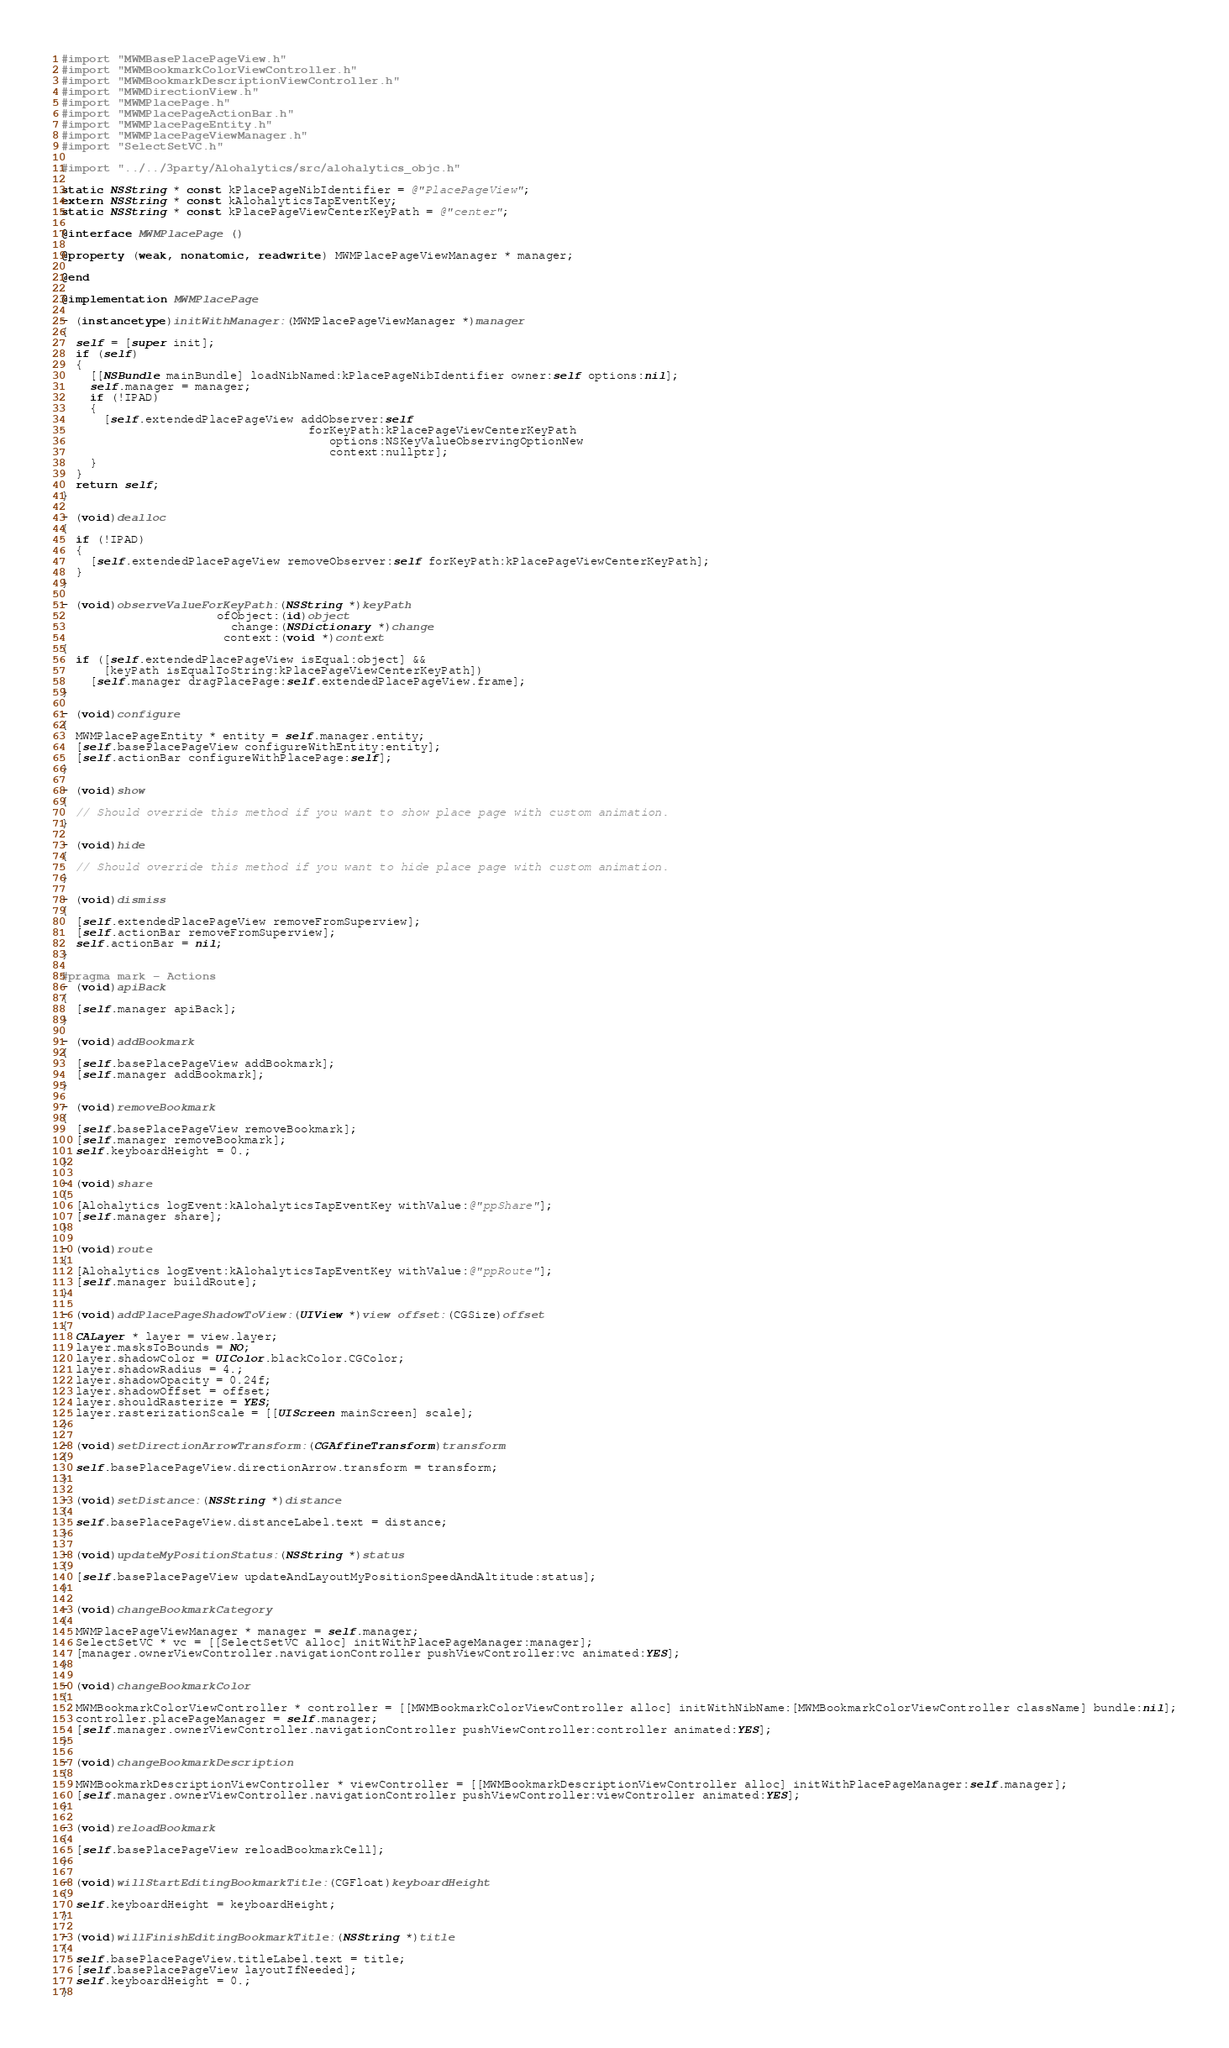Convert code to text. <code><loc_0><loc_0><loc_500><loc_500><_ObjectiveC_>#import "MWMBasePlacePageView.h"
#import "MWMBookmarkColorViewController.h"
#import "MWMBookmarkDescriptionViewController.h"
#import "MWMDirectionView.h"
#import "MWMPlacePage.h"
#import "MWMPlacePageActionBar.h"
#import "MWMPlacePageEntity.h"
#import "MWMPlacePageViewManager.h"
#import "SelectSetVC.h"

#import "../../3party/Alohalytics/src/alohalytics_objc.h"

static NSString * const kPlacePageNibIdentifier = @"PlacePageView";
extern NSString * const kAlohalyticsTapEventKey;
static NSString * const kPlacePageViewCenterKeyPath = @"center";

@interface MWMPlacePage ()

@property (weak, nonatomic, readwrite) MWMPlacePageViewManager * manager;

@end

@implementation MWMPlacePage

- (instancetype)initWithManager:(MWMPlacePageViewManager *)manager
{
  self = [super init];
  if (self)
  {
    [[NSBundle mainBundle] loadNibNamed:kPlacePageNibIdentifier owner:self options:nil];
    self.manager = manager;
    if (!IPAD)
    {
      [self.extendedPlacePageView addObserver:self
                                   forKeyPath:kPlacePageViewCenterKeyPath
                                      options:NSKeyValueObservingOptionNew
                                      context:nullptr];
    }
  }
  return self;
}

- (void)dealloc
{
  if (!IPAD)
  {
    [self.extendedPlacePageView removeObserver:self forKeyPath:kPlacePageViewCenterKeyPath];
  }
}

- (void)observeValueForKeyPath:(NSString *)keyPath
                      ofObject:(id)object
                        change:(NSDictionary *)change
                       context:(void *)context
{
  if ([self.extendedPlacePageView isEqual:object] &&
      [keyPath isEqualToString:kPlacePageViewCenterKeyPath])
    [self.manager dragPlacePage:self.extendedPlacePageView.frame];
}

- (void)configure
{
  MWMPlacePageEntity * entity = self.manager.entity;
  [self.basePlacePageView configureWithEntity:entity];
  [self.actionBar configureWithPlacePage:self];
}

- (void)show
{
  // Should override this method if you want to show place page with custom animation.
}

- (void)hide
{
  // Should override this method if you want to hide place page with custom animation.
}

- (void)dismiss
{
  [self.extendedPlacePageView removeFromSuperview];
  [self.actionBar removeFromSuperview];
  self.actionBar = nil;
}

#pragma mark - Actions
- (void)apiBack
{
  [self.manager apiBack];
}

- (void)addBookmark
{
  [self.basePlacePageView addBookmark];
  [self.manager addBookmark];
}

- (void)removeBookmark
{
  [self.basePlacePageView removeBookmark];
  [self.manager removeBookmark];
  self.keyboardHeight = 0.;
}

- (void)share
{
  [Alohalytics logEvent:kAlohalyticsTapEventKey withValue:@"ppShare"];
  [self.manager share];
}

- (void)route
{
  [Alohalytics logEvent:kAlohalyticsTapEventKey withValue:@"ppRoute"];
  [self.manager buildRoute];
}

- (void)addPlacePageShadowToView:(UIView *)view offset:(CGSize)offset
{
  CALayer * layer = view.layer;
  layer.masksToBounds = NO;
  layer.shadowColor = UIColor.blackColor.CGColor;
  layer.shadowRadius = 4.;
  layer.shadowOpacity = 0.24f;
  layer.shadowOffset = offset;
  layer.shouldRasterize = YES;
  layer.rasterizationScale = [[UIScreen mainScreen] scale];
}

- (void)setDirectionArrowTransform:(CGAffineTransform)transform
{
  self.basePlacePageView.directionArrow.transform = transform;
}

- (void)setDistance:(NSString *)distance
{
  self.basePlacePageView.distanceLabel.text = distance;
}

- (void)updateMyPositionStatus:(NSString *)status
{
  [self.basePlacePageView updateAndLayoutMyPositionSpeedAndAltitude:status];
}

- (void)changeBookmarkCategory
{
  MWMPlacePageViewManager * manager = self.manager;
  SelectSetVC * vc = [[SelectSetVC alloc] initWithPlacePageManager:manager];
  [manager.ownerViewController.navigationController pushViewController:vc animated:YES];
}

- (void)changeBookmarkColor
{
  MWMBookmarkColorViewController * controller = [[MWMBookmarkColorViewController alloc] initWithNibName:[MWMBookmarkColorViewController className] bundle:nil];
  controller.placePageManager = self.manager;
  [self.manager.ownerViewController.navigationController pushViewController:controller animated:YES];
}

- (void)changeBookmarkDescription
{
  MWMBookmarkDescriptionViewController * viewController = [[MWMBookmarkDescriptionViewController alloc] initWithPlacePageManager:self.manager];
  [self.manager.ownerViewController.navigationController pushViewController:viewController animated:YES];
}

- (void)reloadBookmark
{
  [self.basePlacePageView reloadBookmarkCell];
}

- (void)willStartEditingBookmarkTitle:(CGFloat)keyboardHeight
{
  self.keyboardHeight = keyboardHeight;
}

- (void)willFinishEditingBookmarkTitle:(NSString *)title
{
  self.basePlacePageView.titleLabel.text = title;
  [self.basePlacePageView layoutIfNeeded];
  self.keyboardHeight = 0.;
}
</code> 